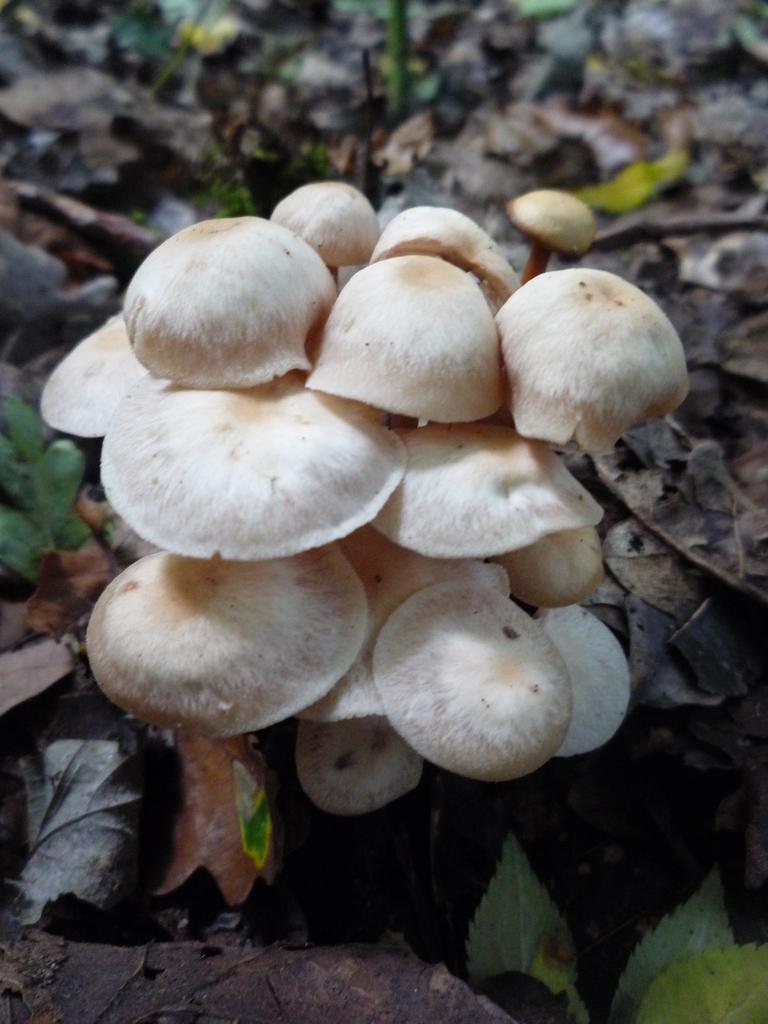Describe this image in one or two sentences. In the image there are mushrooms. On the ground there are dry leaves. 